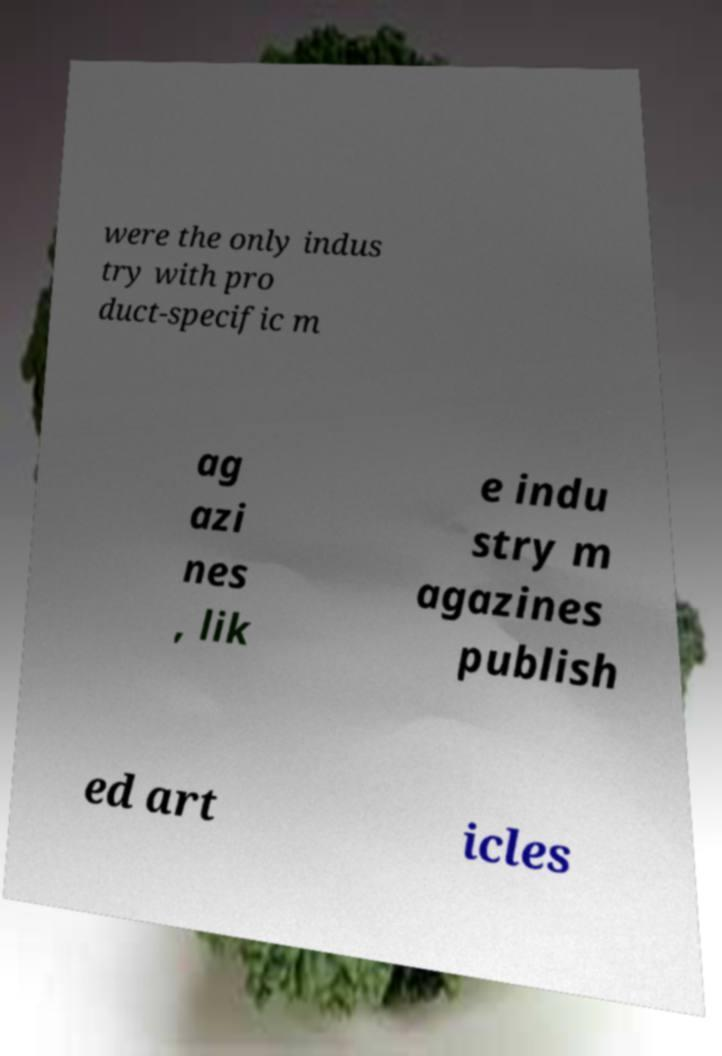Please read and relay the text visible in this image. What does it say? were the only indus try with pro duct-specific m ag azi nes , lik e indu stry m agazines publish ed art icles 